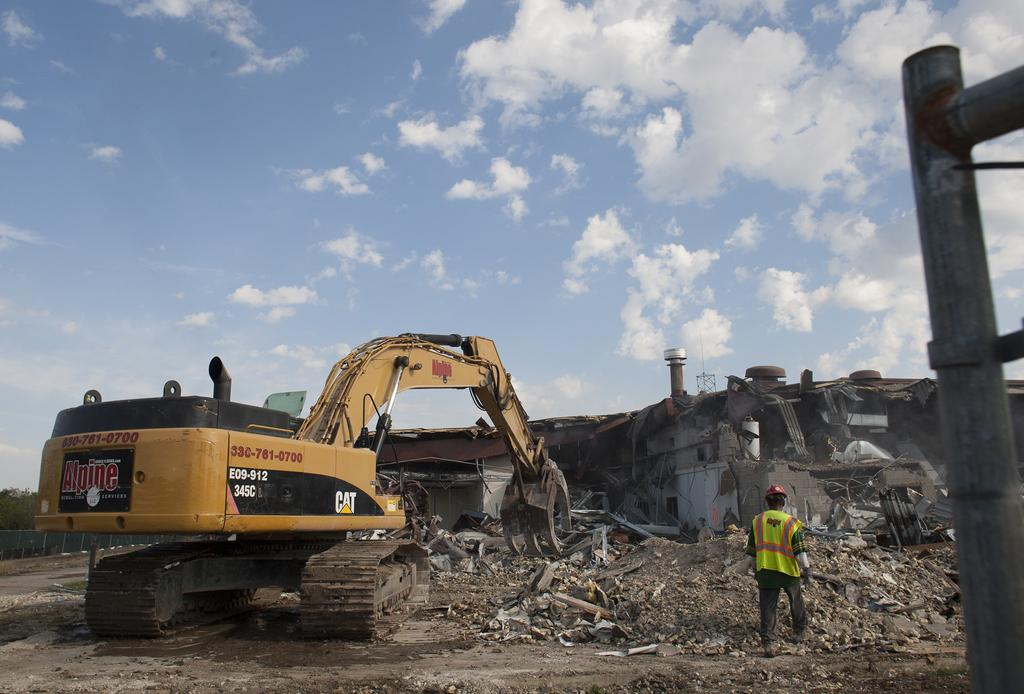What is the main subject in the image? There is a person standing in the image. What else can be seen in the image besides the person? There is a vehicle, a collapsed building, trees, and the sky visible in the background of the image. What type of sound can be heard coming from the office in the image? There is no office present in the image, so it's not possible to determine what, if any, sounds might be heard. 